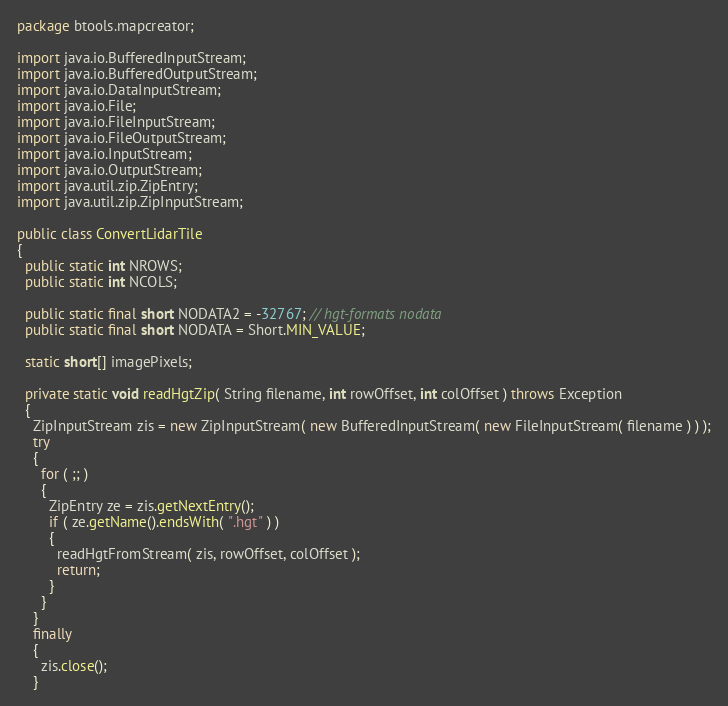Convert code to text. <code><loc_0><loc_0><loc_500><loc_500><_Java_>package btools.mapcreator;

import java.io.BufferedInputStream;
import java.io.BufferedOutputStream;
import java.io.DataInputStream;
import java.io.File;
import java.io.FileInputStream;
import java.io.FileOutputStream;
import java.io.InputStream;
import java.io.OutputStream;
import java.util.zip.ZipEntry;
import java.util.zip.ZipInputStream;

public class ConvertLidarTile
{
  public static int NROWS;
  public static int NCOLS;

  public static final short NODATA2 = -32767; // hgt-formats nodata
  public static final short NODATA = Short.MIN_VALUE;

  static short[] imagePixels;

  private static void readHgtZip( String filename, int rowOffset, int colOffset ) throws Exception
  {
    ZipInputStream zis = new ZipInputStream( new BufferedInputStream( new FileInputStream( filename ) ) );
    try
    {
      for ( ;; )
      {
        ZipEntry ze = zis.getNextEntry();
        if ( ze.getName().endsWith( ".hgt" ) )
        {
          readHgtFromStream( zis, rowOffset, colOffset );
          return;
        }
      }
    }
    finally
    {
      zis.close();
    }</code> 